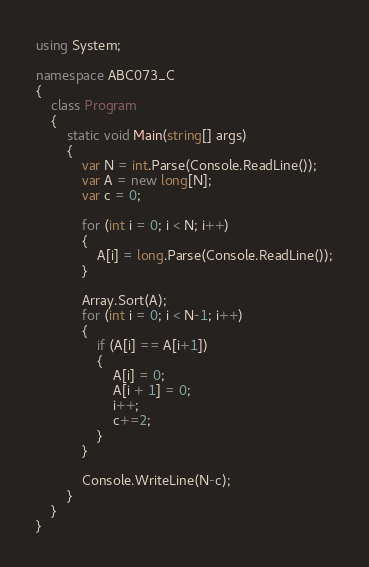Convert code to text. <code><loc_0><loc_0><loc_500><loc_500><_C#_>using System;

namespace ABC073_C
{
    class Program
    {
        static void Main(string[] args)
        {
            var N = int.Parse(Console.ReadLine());
            var A = new long[N];
            var c = 0;

            for (int i = 0; i < N; i++)
            {
                A[i] = long.Parse(Console.ReadLine());
            }

            Array.Sort(A);
            for (int i = 0; i < N-1; i++)
            {
                if (A[i] == A[i+1])
                {
                    A[i] = 0;
                    A[i + 1] = 0;
                    i++;
                    c+=2;
                }
            }

            Console.WriteLine(N-c);
        }
    }
}
</code> 